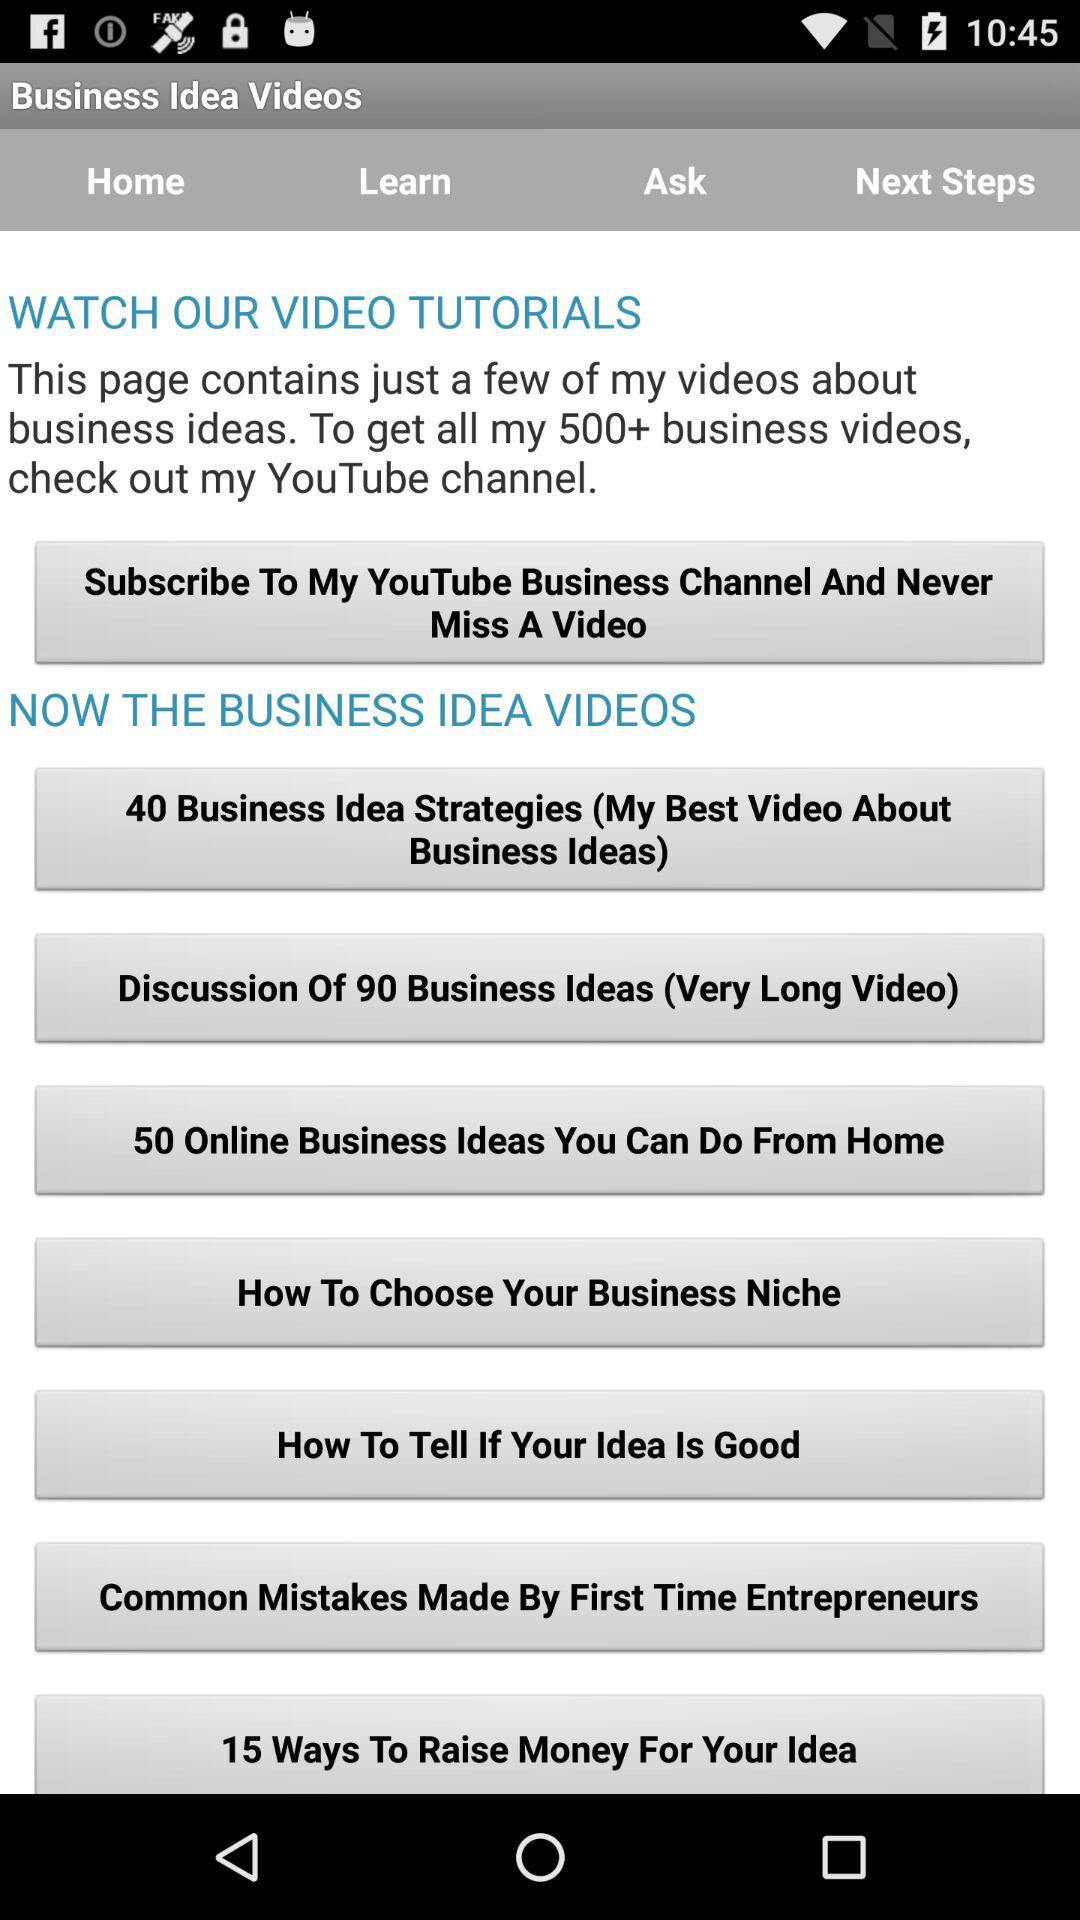How many ways are mentioned to raise money? There are 15 ways mentioned to raise money. 